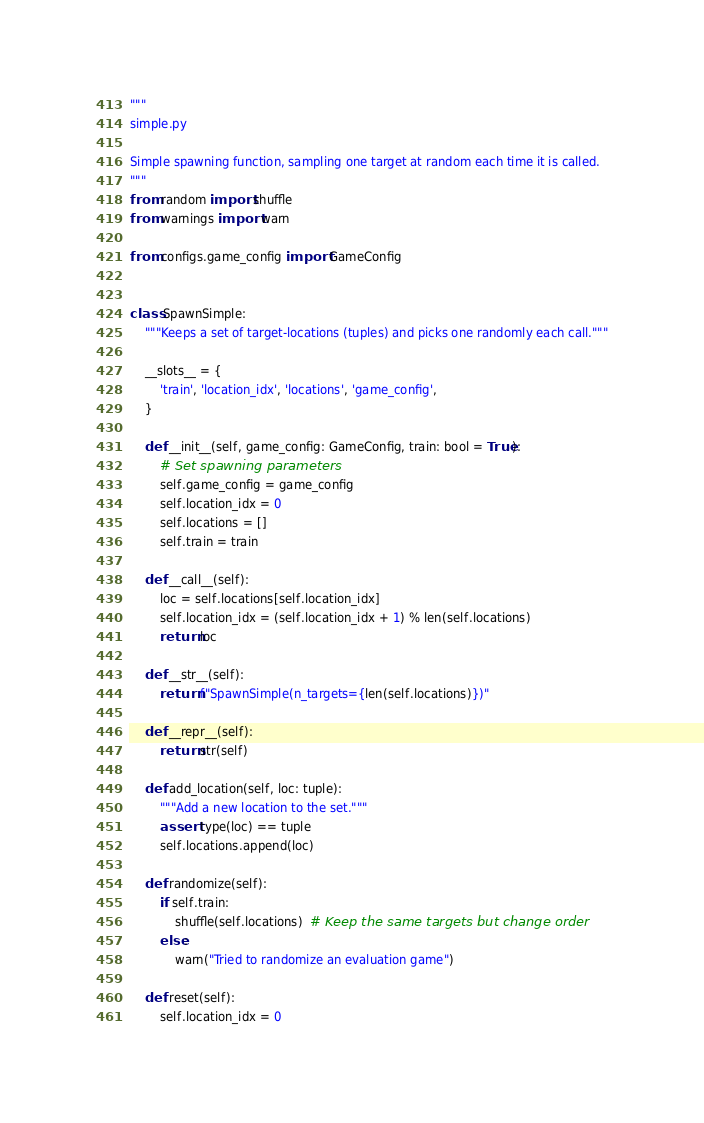Convert code to text. <code><loc_0><loc_0><loc_500><loc_500><_Python_>"""
simple.py

Simple spawning function, sampling one target at random each time it is called.
"""
from random import shuffle
from warnings import warn

from configs.game_config import GameConfig


class SpawnSimple:
    """Keeps a set of target-locations (tuples) and picks one randomly each call."""
    
    __slots__ = {
        'train', 'location_idx', 'locations', 'game_config',
    }
    
    def __init__(self, game_config: GameConfig, train: bool = True):
        # Set spawning parameters
        self.game_config = game_config
        self.location_idx = 0
        self.locations = []
        self.train = train
    
    def __call__(self):
        loc = self.locations[self.location_idx]
        self.location_idx = (self.location_idx + 1) % len(self.locations)
        return loc
    
    def __str__(self):
        return f"SpawnSimple(n_targets={len(self.locations)})"
    
    def __repr__(self):
        return str(self)
    
    def add_location(self, loc: tuple):
        """Add a new location to the set."""
        assert type(loc) == tuple
        self.locations.append(loc)
    
    def randomize(self):
        if self.train:
            shuffle(self.locations)  # Keep the same targets but change order
        else:
            warn("Tried to randomize an evaluation game")
    
    def reset(self):
        self.location_idx = 0
</code> 